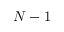Convert formula to latex. <formula><loc_0><loc_0><loc_500><loc_500>N - 1</formula> 